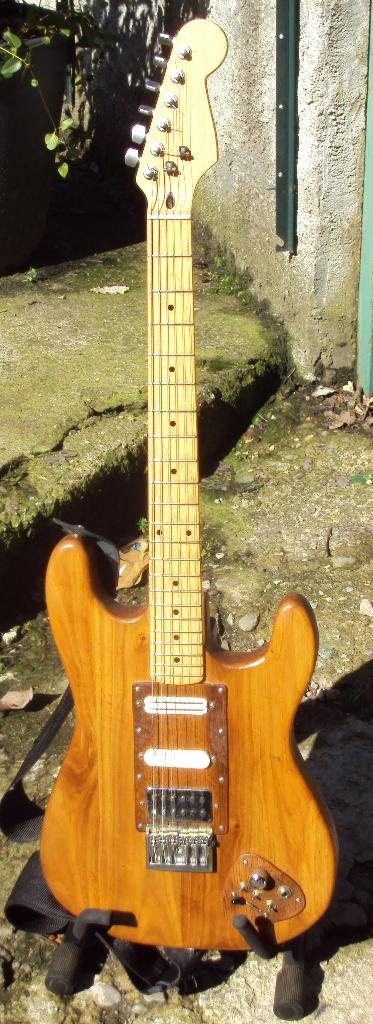What musical instrument is present in the image? There is a guitar in the image. What type of cheese is being played on the guitar in the image? There is no cheese present in the image, and the guitar is not being played with cheese. 